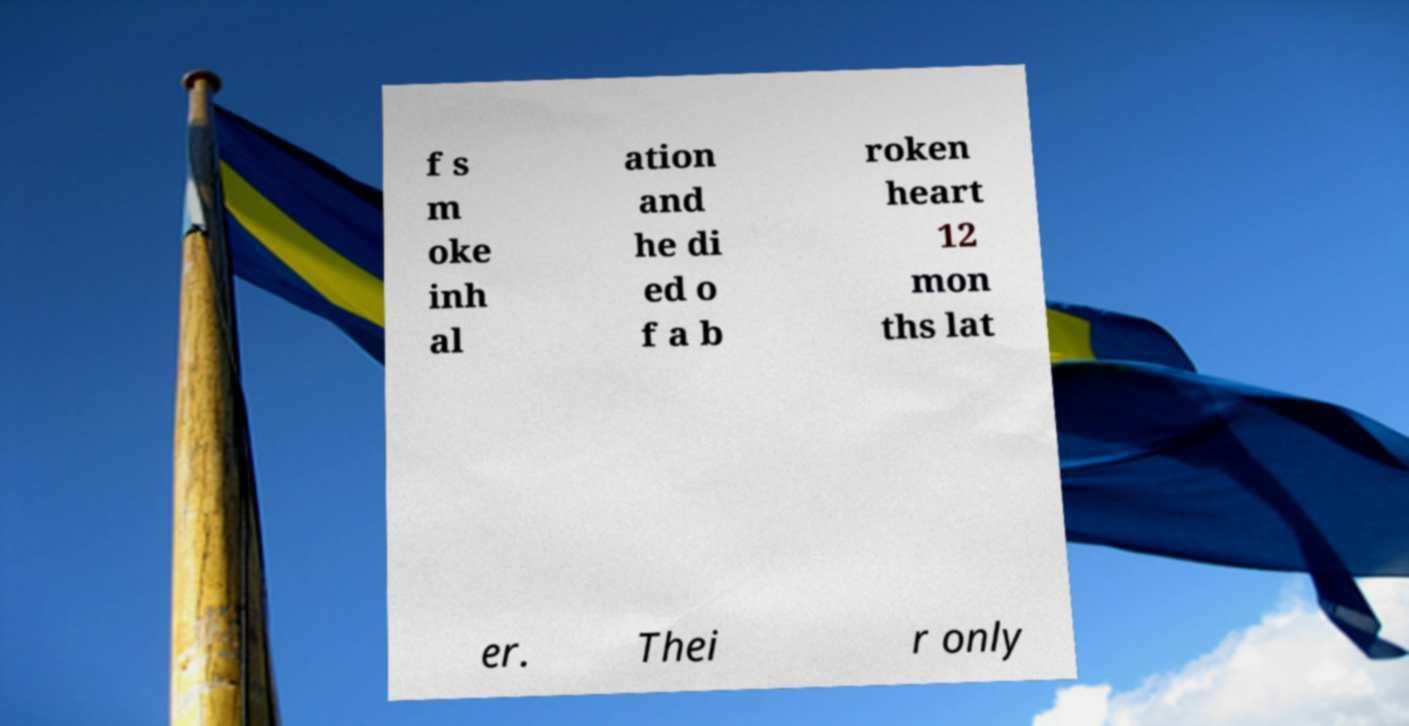Please identify and transcribe the text found in this image. f s m oke inh al ation and he di ed o f a b roken heart 12 mon ths lat er. Thei r only 